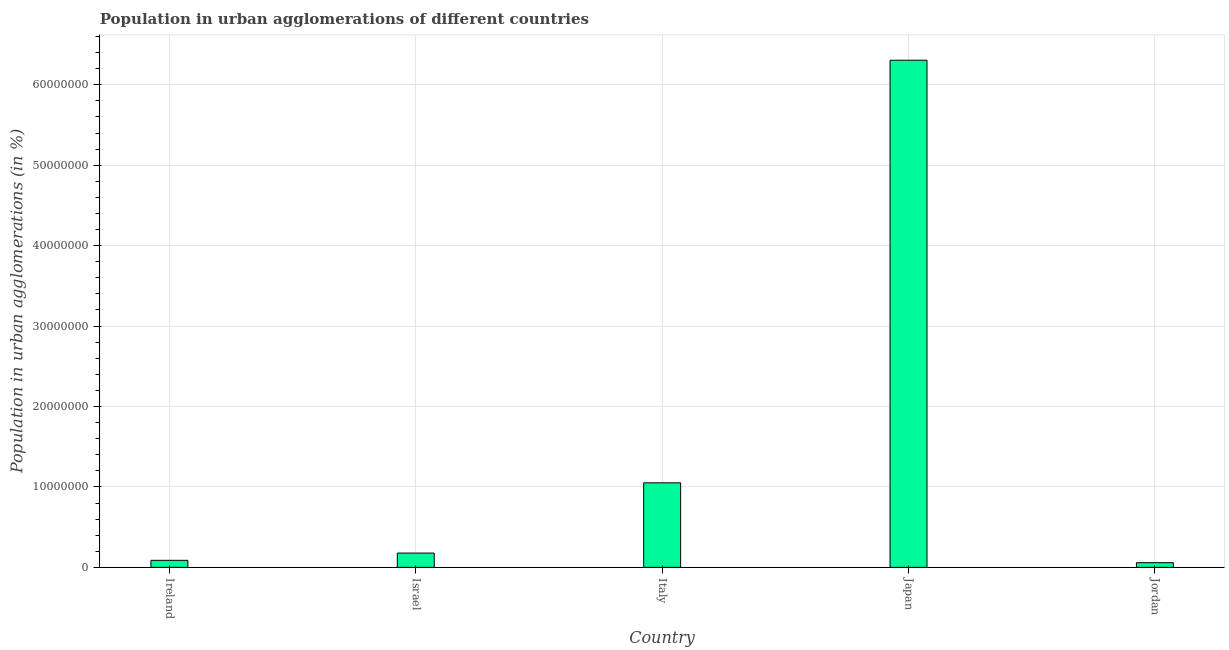Does the graph contain any zero values?
Provide a short and direct response. No. Does the graph contain grids?
Ensure brevity in your answer.  Yes. What is the title of the graph?
Provide a short and direct response. Population in urban agglomerations of different countries. What is the label or title of the X-axis?
Ensure brevity in your answer.  Country. What is the label or title of the Y-axis?
Offer a terse response. Population in urban agglomerations (in %). What is the population in urban agglomerations in Ireland?
Keep it short and to the point. 8.75e+05. Across all countries, what is the maximum population in urban agglomerations?
Ensure brevity in your answer.  6.31e+07. Across all countries, what is the minimum population in urban agglomerations?
Your response must be concise. 5.82e+05. In which country was the population in urban agglomerations minimum?
Provide a succinct answer. Jordan. What is the sum of the population in urban agglomerations?
Offer a very short reply. 7.68e+07. What is the difference between the population in urban agglomerations in Italy and Jordan?
Keep it short and to the point. 9.93e+06. What is the average population in urban agglomerations per country?
Keep it short and to the point. 1.54e+07. What is the median population in urban agglomerations?
Make the answer very short. 1.78e+06. What is the ratio of the population in urban agglomerations in Ireland to that in Jordan?
Provide a succinct answer. 1.5. What is the difference between the highest and the second highest population in urban agglomerations?
Your response must be concise. 5.25e+07. What is the difference between the highest and the lowest population in urban agglomerations?
Ensure brevity in your answer.  6.25e+07. In how many countries, is the population in urban agglomerations greater than the average population in urban agglomerations taken over all countries?
Ensure brevity in your answer.  1. How many countries are there in the graph?
Make the answer very short. 5. What is the Population in urban agglomerations (in %) of Ireland?
Give a very brief answer. 8.75e+05. What is the Population in urban agglomerations (in %) in Israel?
Provide a short and direct response. 1.78e+06. What is the Population in urban agglomerations (in %) in Italy?
Make the answer very short. 1.05e+07. What is the Population in urban agglomerations (in %) of Japan?
Provide a short and direct response. 6.31e+07. What is the Population in urban agglomerations (in %) of Jordan?
Ensure brevity in your answer.  5.82e+05. What is the difference between the Population in urban agglomerations (in %) in Ireland and Israel?
Ensure brevity in your answer.  -9.02e+05. What is the difference between the Population in urban agglomerations (in %) in Ireland and Italy?
Ensure brevity in your answer.  -9.63e+06. What is the difference between the Population in urban agglomerations (in %) in Ireland and Japan?
Your response must be concise. -6.22e+07. What is the difference between the Population in urban agglomerations (in %) in Ireland and Jordan?
Provide a succinct answer. 2.92e+05. What is the difference between the Population in urban agglomerations (in %) in Israel and Italy?
Provide a short and direct response. -8.73e+06. What is the difference between the Population in urban agglomerations (in %) in Israel and Japan?
Provide a succinct answer. -6.13e+07. What is the difference between the Population in urban agglomerations (in %) in Israel and Jordan?
Make the answer very short. 1.19e+06. What is the difference between the Population in urban agglomerations (in %) in Italy and Japan?
Your answer should be very brief. -5.25e+07. What is the difference between the Population in urban agglomerations (in %) in Italy and Jordan?
Give a very brief answer. 9.93e+06. What is the difference between the Population in urban agglomerations (in %) in Japan and Jordan?
Ensure brevity in your answer.  6.25e+07. What is the ratio of the Population in urban agglomerations (in %) in Ireland to that in Israel?
Give a very brief answer. 0.49. What is the ratio of the Population in urban agglomerations (in %) in Ireland to that in Italy?
Your answer should be compact. 0.08. What is the ratio of the Population in urban agglomerations (in %) in Ireland to that in Japan?
Offer a very short reply. 0.01. What is the ratio of the Population in urban agglomerations (in %) in Ireland to that in Jordan?
Keep it short and to the point. 1.5. What is the ratio of the Population in urban agglomerations (in %) in Israel to that in Italy?
Make the answer very short. 0.17. What is the ratio of the Population in urban agglomerations (in %) in Israel to that in Japan?
Your response must be concise. 0.03. What is the ratio of the Population in urban agglomerations (in %) in Israel to that in Jordan?
Make the answer very short. 3.05. What is the ratio of the Population in urban agglomerations (in %) in Italy to that in Japan?
Give a very brief answer. 0.17. What is the ratio of the Population in urban agglomerations (in %) in Italy to that in Jordan?
Your response must be concise. 18.05. What is the ratio of the Population in urban agglomerations (in %) in Japan to that in Jordan?
Provide a succinct answer. 108.3. 